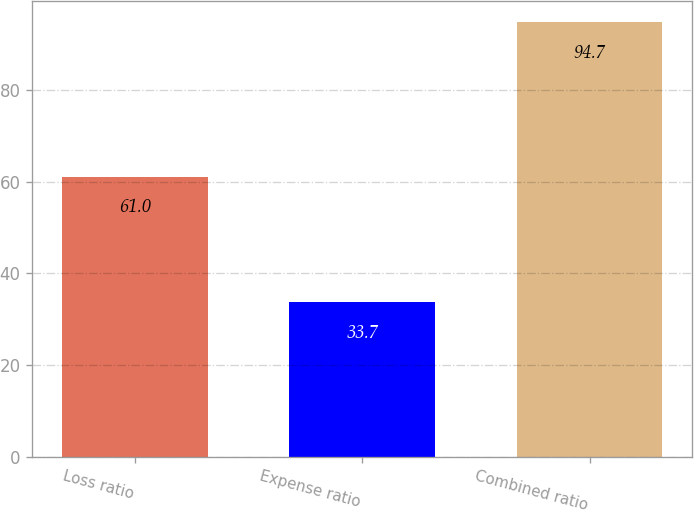<chart> <loc_0><loc_0><loc_500><loc_500><bar_chart><fcel>Loss ratio<fcel>Expense ratio<fcel>Combined ratio<nl><fcel>61<fcel>33.7<fcel>94.7<nl></chart> 